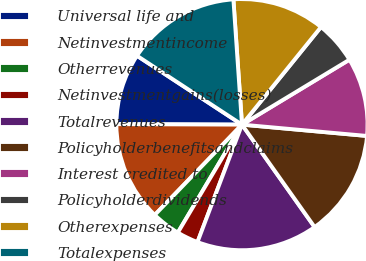Convert chart to OTSL. <chart><loc_0><loc_0><loc_500><loc_500><pie_chart><fcel>Universal life and<fcel>Netinvestmentincome<fcel>Otherrevenues<fcel>Netinvestmentgains(losses)<fcel>Totalrevenues<fcel>Policyholderbenefitsandclaims<fcel>Interest credited to<fcel>Policyholderdividends<fcel>Otherexpenses<fcel>Totalexpenses<nl><fcel>9.18%<fcel>12.84%<fcel>3.69%<fcel>2.77%<fcel>15.58%<fcel>13.75%<fcel>10.09%<fcel>5.52%<fcel>11.92%<fcel>14.67%<nl></chart> 